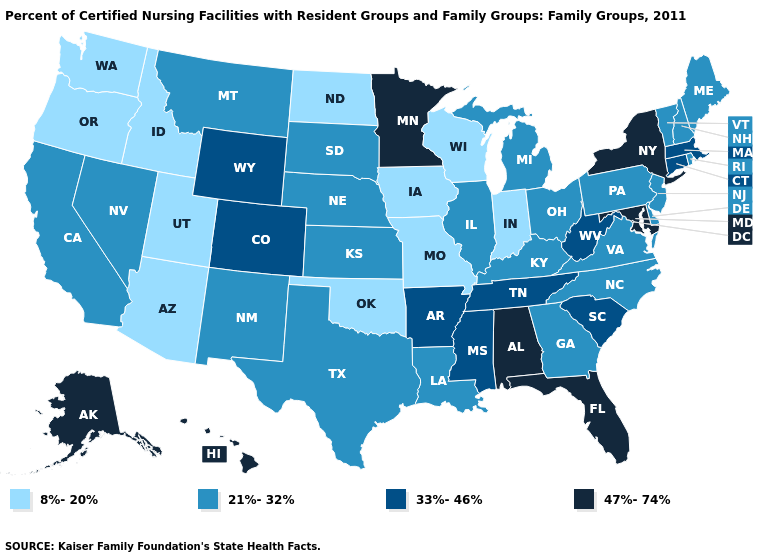Among the states that border Colorado , which have the highest value?
Keep it brief. Wyoming. What is the value of Georgia?
Concise answer only. 21%-32%. Name the states that have a value in the range 8%-20%?
Concise answer only. Arizona, Idaho, Indiana, Iowa, Missouri, North Dakota, Oklahoma, Oregon, Utah, Washington, Wisconsin. Does Indiana have the highest value in the USA?
Answer briefly. No. Among the states that border Texas , does Oklahoma have the highest value?
Concise answer only. No. What is the highest value in states that border Utah?
Answer briefly. 33%-46%. What is the value of Massachusetts?
Give a very brief answer. 33%-46%. What is the value of Missouri?
Concise answer only. 8%-20%. What is the lowest value in the USA?
Quick response, please. 8%-20%. What is the value of Arizona?
Write a very short answer. 8%-20%. What is the value of Illinois?
Write a very short answer. 21%-32%. Does Oklahoma have the lowest value in the South?
Short answer required. Yes. Does Ohio have the highest value in the USA?
Write a very short answer. No. What is the value of Washington?
Concise answer only. 8%-20%. 